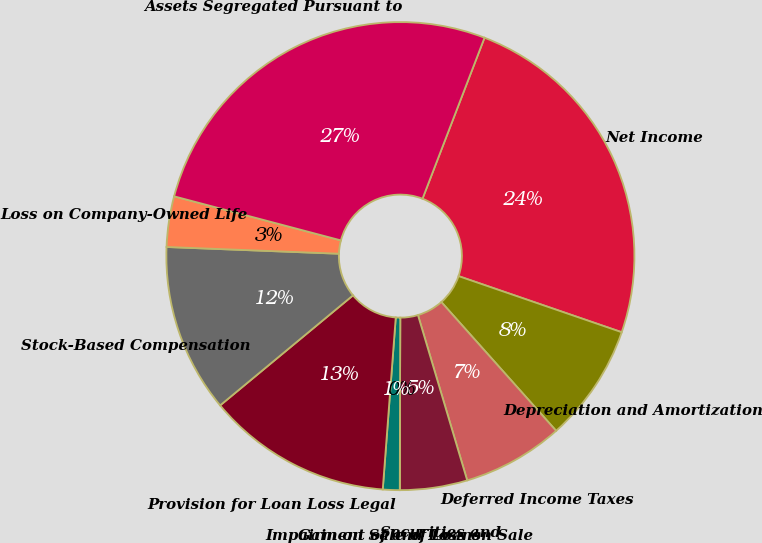Convert chart to OTSL. <chart><loc_0><loc_0><loc_500><loc_500><pie_chart><fcel>Net Income<fcel>Depreciation and Amortization<fcel>Deferred Income Taxes<fcel>Securities and<fcel>Impairment of and Loss on Sale<fcel>Gain on Sale of Loans<fcel>Provision for Loan Loss Legal<fcel>Stock-Based Compensation<fcel>Loss on Company-Owned Life<fcel>Assets Segregated Pursuant to<nl><fcel>24.42%<fcel>8.14%<fcel>6.98%<fcel>4.65%<fcel>0.0%<fcel>1.16%<fcel>12.79%<fcel>11.63%<fcel>3.49%<fcel>26.74%<nl></chart> 